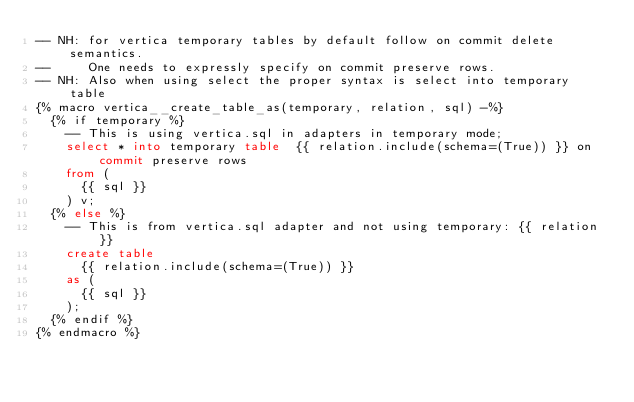<code> <loc_0><loc_0><loc_500><loc_500><_SQL_>-- NH: for vertica temporary tables by default follow on commit delete semantics.
--     One needs to expressly specify on commit preserve rows.
-- NH: Also when using select the proper syntax is select into temporary table
{% macro vertica__create_table_as(temporary, relation, sql) -%}
  {% if temporary %}
    -- This is using vertica.sql in adapters in temporary mode;
    select * into temporary table  {{ relation.include(schema=(True)) }} on commit preserve rows
    from (
      {{ sql }}
    ) v;
  {% else %}
    -- This is from vertica.sql adapter and not using temporary: {{ relation }}
    create table
      {{ relation.include(schema=(True)) }}
    as (
      {{ sql }}
    );
  {% endif %}
{% endmacro %}
</code> 